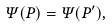Convert formula to latex. <formula><loc_0><loc_0><loc_500><loc_500>\Psi ( P ) = \Psi ( P ^ { \prime } ) ,</formula> 